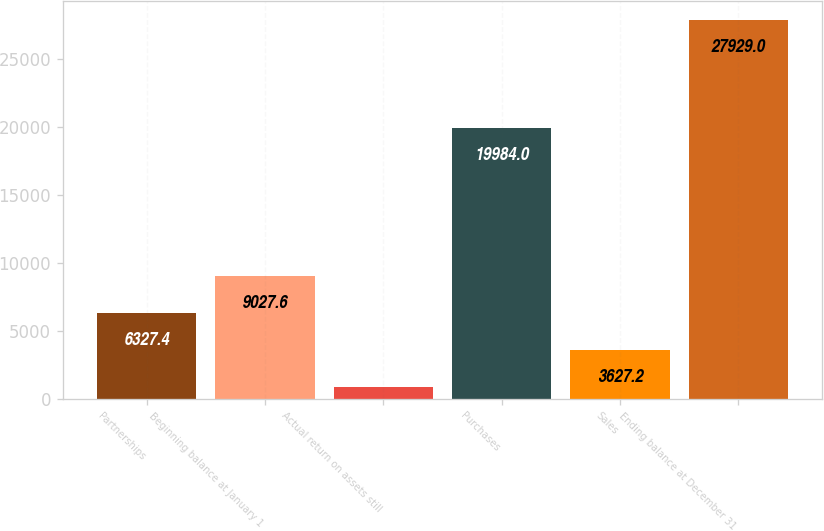Convert chart to OTSL. <chart><loc_0><loc_0><loc_500><loc_500><bar_chart><fcel>Partnerships<fcel>Beginning balance at January 1<fcel>Actual return on assets still<fcel>Purchases<fcel>Sales<fcel>Ending balance at December 31<nl><fcel>6327.4<fcel>9027.6<fcel>927<fcel>19984<fcel>3627.2<fcel>27929<nl></chart> 